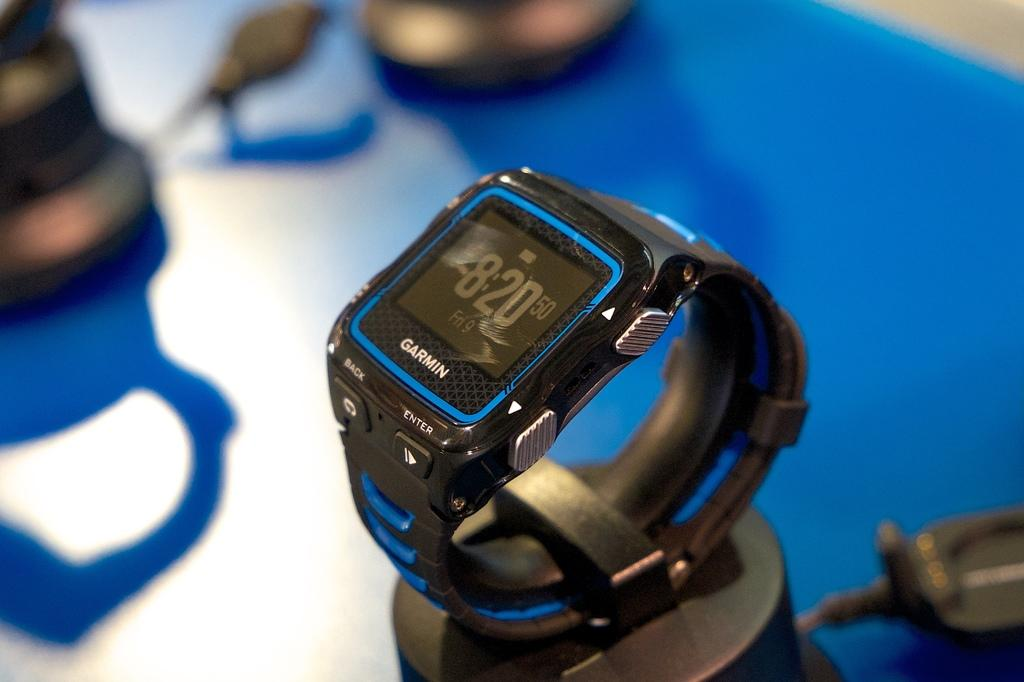<image>
Give a short and clear explanation of the subsequent image. Stopwatch that has the time set at 8:20. 